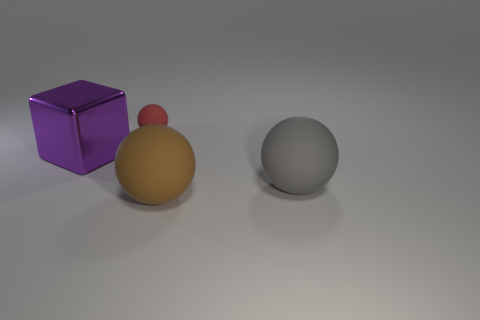Add 1 green shiny cubes. How many objects exist? 5 Subtract all blocks. How many objects are left? 3 Add 3 big metallic blocks. How many big metallic blocks are left? 4 Add 2 small rubber things. How many small rubber things exist? 3 Subtract 0 blue cubes. How many objects are left? 4 Subtract all small matte spheres. Subtract all big shiny objects. How many objects are left? 2 